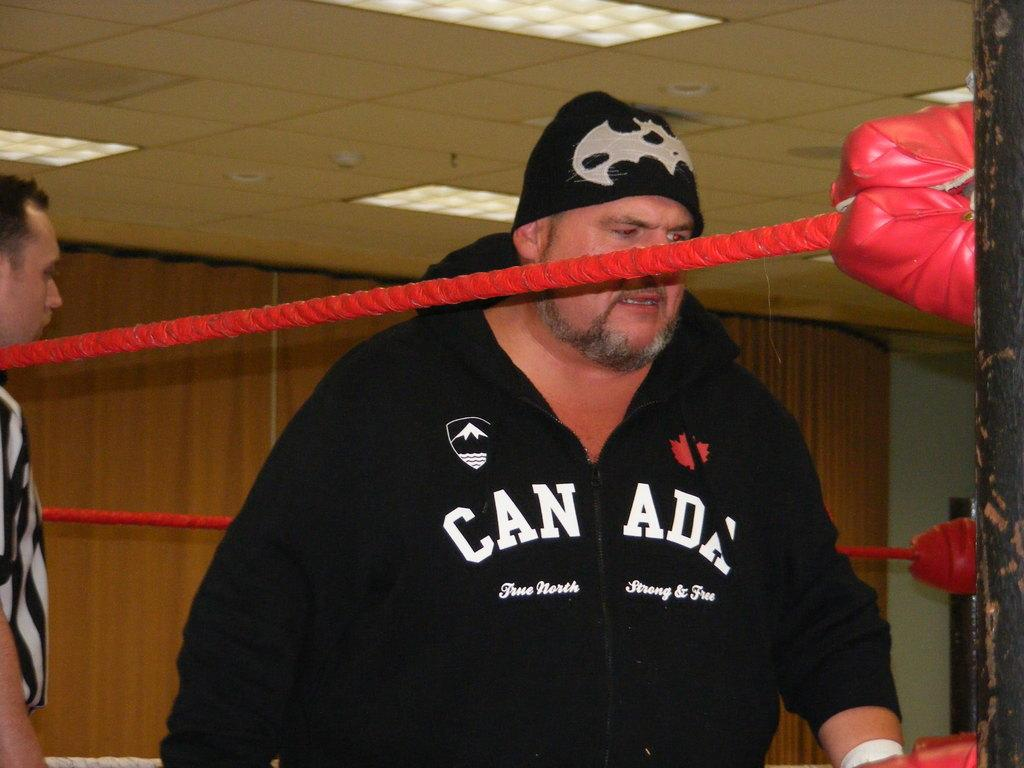<image>
Create a compact narrative representing the image presented. A man in a black hoodie that says Canada is in a boxing ring. 